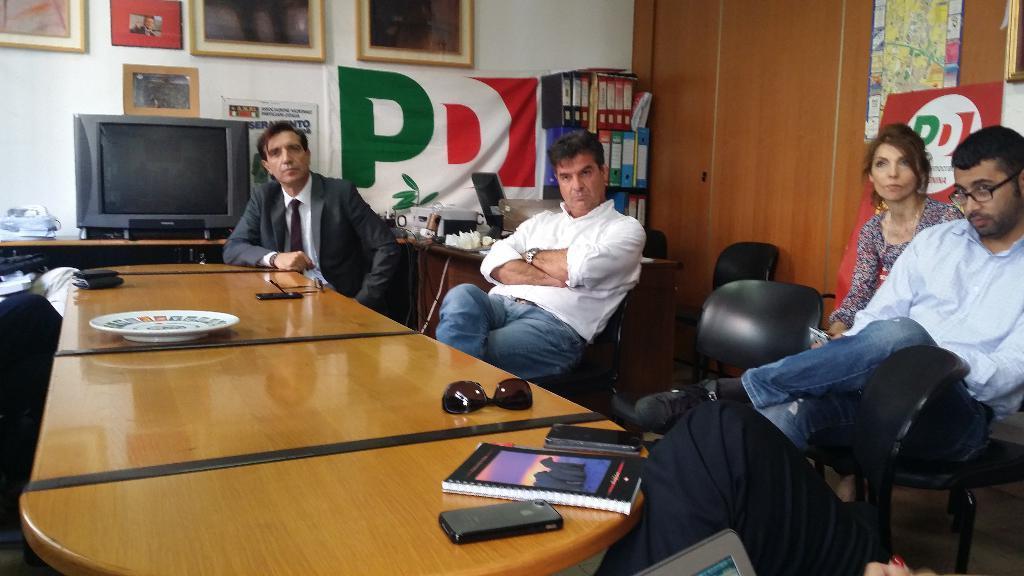In one or two sentences, can you explain what this image depicts? In this image I can see few people are sitting on chairs, I can also see he is wearing a specs. Here on this table I can see a wallet, a plate, a shades, few phones and a book. In the background I can see few frames, a banner on this wall. I can also see a television. 